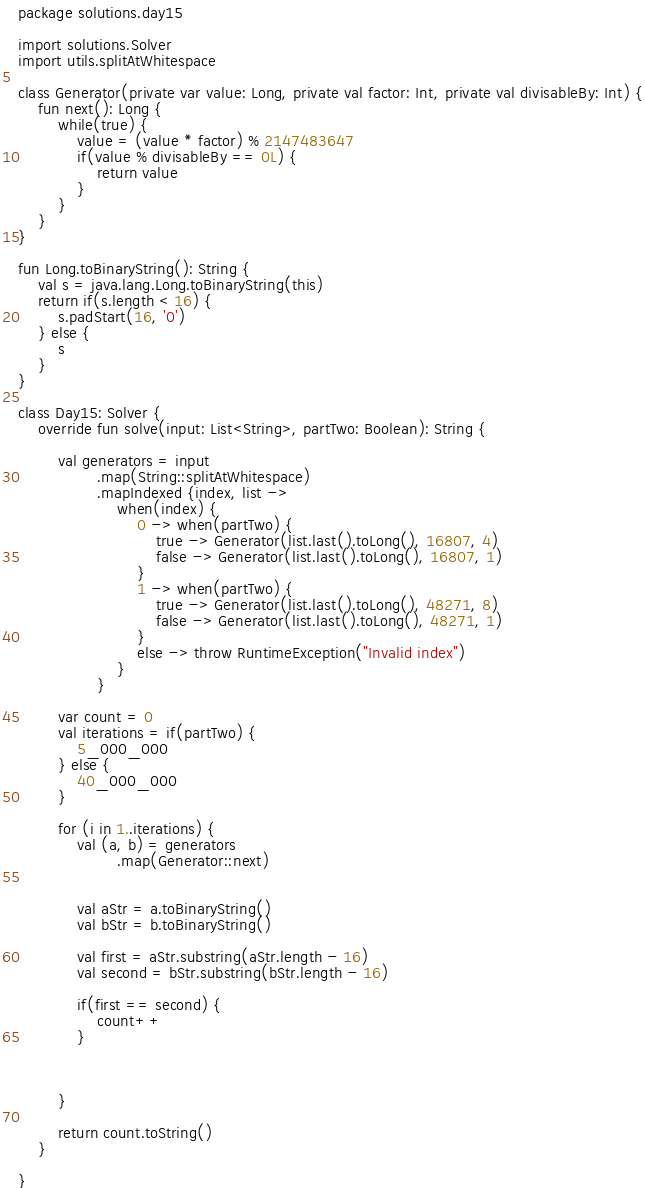<code> <loc_0><loc_0><loc_500><loc_500><_Kotlin_>package solutions.day15

import solutions.Solver
import utils.splitAtWhitespace

class Generator(private var value: Long, private val factor: Int, private val divisableBy: Int) {
    fun next(): Long {
        while(true) {
            value = (value * factor) % 2147483647
            if(value % divisableBy == 0L) {
                return value
            }
        }
    }
}

fun Long.toBinaryString(): String {
    val s = java.lang.Long.toBinaryString(this)
    return if(s.length < 16) {
        s.padStart(16, '0')
    } else {
        s
    }
}

class Day15: Solver {
    override fun solve(input: List<String>, partTwo: Boolean): String {

        val generators = input
                .map(String::splitAtWhitespace)
                .mapIndexed {index, list ->
                    when(index) {
                        0 -> when(partTwo) {
                            true -> Generator(list.last().toLong(), 16807, 4)
                            false -> Generator(list.last().toLong(), 16807, 1)
                        }
                        1 -> when(partTwo) {
                            true -> Generator(list.last().toLong(), 48271, 8)
                            false -> Generator(list.last().toLong(), 48271, 1)
                        }
                        else -> throw RuntimeException("Invalid index")
                    }
                }

        var count = 0
        val iterations = if(partTwo) {
            5_000_000
        } else {
            40_000_000
        }

        for (i in 1..iterations) {
            val (a, b) = generators
                    .map(Generator::next)


            val aStr = a.toBinaryString()
            val bStr = b.toBinaryString()

            val first = aStr.substring(aStr.length - 16)
            val second = bStr.substring(bStr.length - 16)

            if(first == second) {
                count++
            }



        }

        return count.toString()
    }

}</code> 